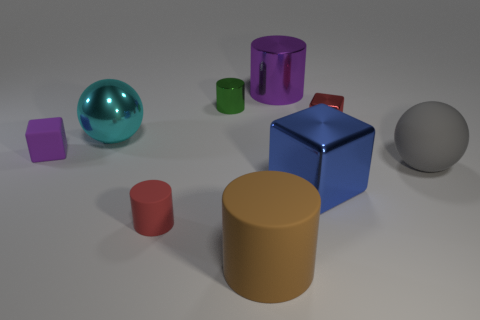Subtract all brown cylinders. How many cylinders are left? 3 Subtract all red cylinders. How many cylinders are left? 3 Subtract 1 balls. How many balls are left? 1 Subtract all cubes. How many objects are left? 6 Subtract all brown blocks. Subtract all purple spheres. How many blocks are left? 3 Subtract all yellow objects. Subtract all big matte cylinders. How many objects are left? 8 Add 5 big blue metallic blocks. How many big blue metallic blocks are left? 6 Add 1 tiny yellow metallic cubes. How many tiny yellow metallic cubes exist? 1 Subtract 1 green cylinders. How many objects are left? 8 